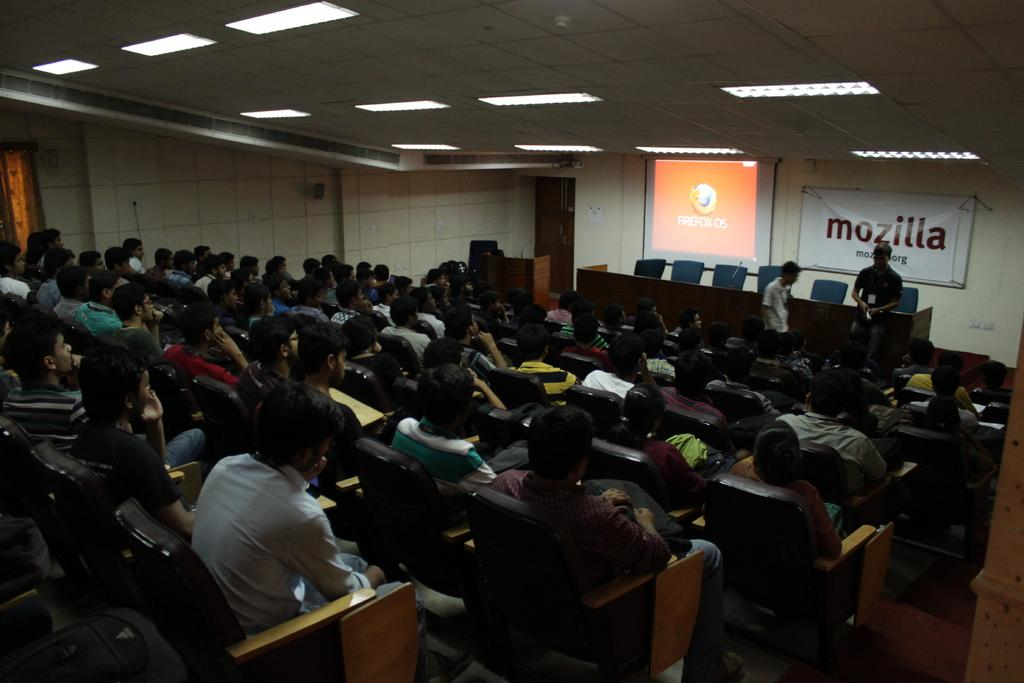What is the main object in the image? There is a screen in the image. What is the color of the wall behind the screen? There is a white color wall in the image. What is hanging on the wall? There is a banner in the image. What type of furniture is present in the image? There are chairs and tables in the image. What are the people in the image doing? There are people sitting on chairs in the image. What type of appliance is being used to poison the people in the image? There is no appliance or poison present in the image; it only shows people sitting on chairs in front of a screen. 